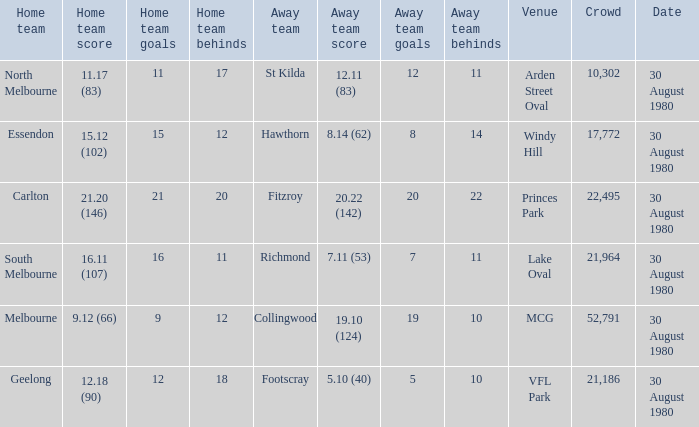What was the crowd when the away team is footscray? 21186.0. 